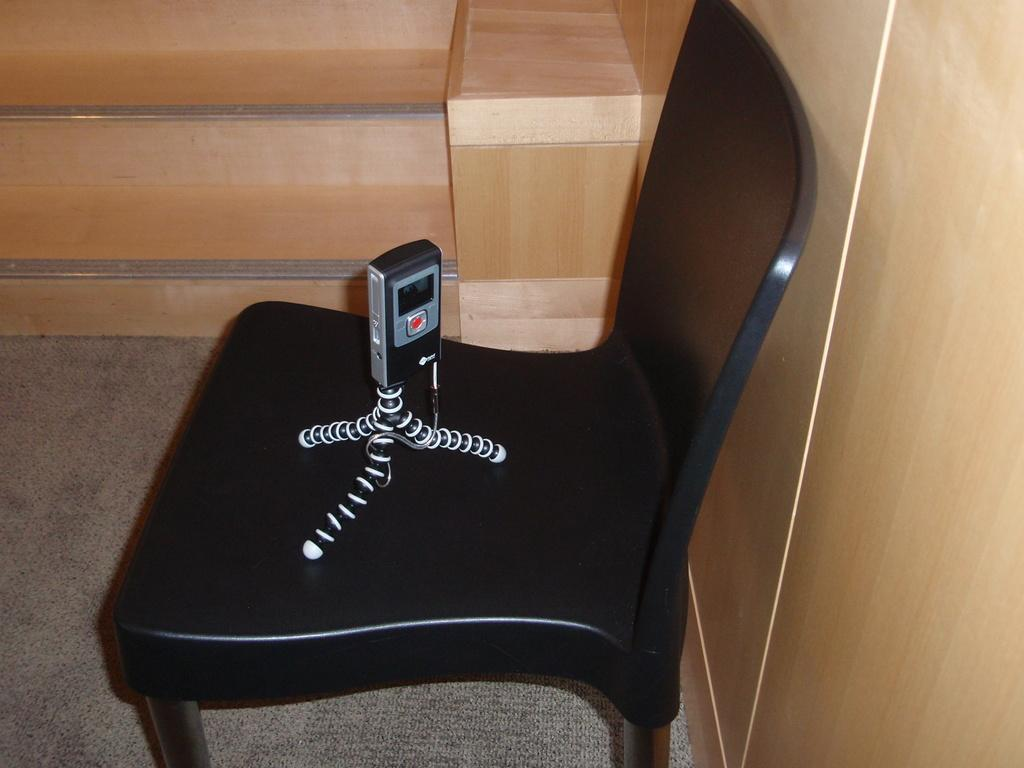What type of furniture is present in the image? There is a chair in the image. What is placed on the chair? An object is kept on the chair. Are there any architectural features visible in the image? Yes, there are steps in the image. What material is used for the wall in the image? There is a wooden wall in the image. What type of space might the image be depicting? The image is likely taken in a room. Can you see any snow falling outside the window in the image? There is no window or snow visible in the image. Are there any goldfish swimming in the wooden wall in the image? There are no goldfish present in the image; it features a chair, an object on the chair, steps, and a wooden wall. 